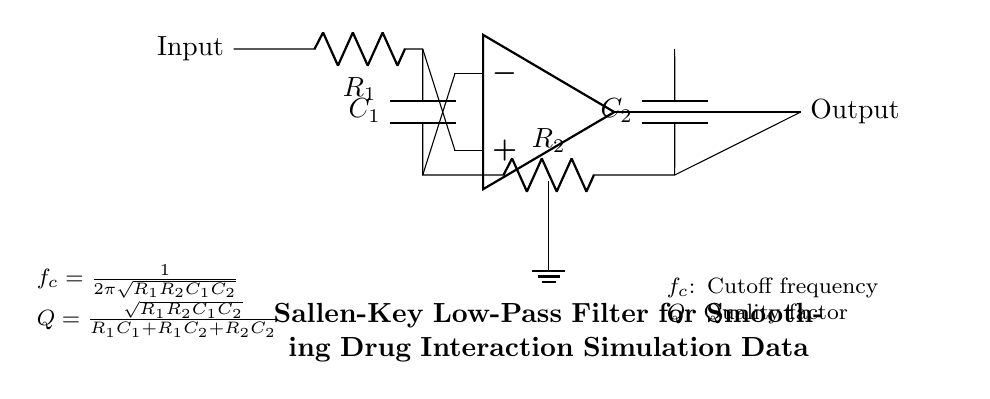What type of filter is this circuit? This circuit is a Sallen-Key low-pass filter, which is indicated by the title in the circuit diagram. A low-pass filter allows signals with a frequency lower than a certain cutoff frequency to pass through while attenuating frequencies higher than the cutoff.
Answer: Sallen-Key low-pass filter What are the values of the resistors in the circuit? The circuit specifies resistor values as R1 and R2, which are labeled next to the respective components. However, the exact numerical values are not provided in this circuit diagram.
Answer: R1, R2 What is the function of the operational amplifier in this circuit? The operational amplifier amplifies the difference between the input and feedback signals, which enables the smoothing effect of the filter. It is an active component used in this filter to control the gain and improve the filtering performance.
Answer: Amplification What is the formula for the cutoff frequency? The formula for the cutoff frequency is given below the circuit as f_c = 1 / (2π√(R1R2C1C2)). This requires recognizing the formula's structure and identifying the components contributing to the calculation of cutoff frequency.
Answer: 1 / (2π√(R1R2C1C2)) How is the quality factor (Q) calculated in this filter? The quality factor Q is calculated using the formula Q = √(R1R2C1C2) / (R1C1 + R1C2 + R2C2), which shows how the components work together to define the filter's response sharpness and selectivity. This involves analyzing the relationships between resistors and capacitors in the circuit.
Answer: √(R1R2C1C2) / (R1C1 + R1C2 + R2C2) What role do capacitors C1 and C2 serve in this circuit? Capacitors C1 and C2 store energy and control the charging and discharging rates, which are critical for smoothing the output signal by affecting the filter's frequency response. They contribute to determining the cutoff frequency alongside the resistors.
Answer: Energy storage and filtering 